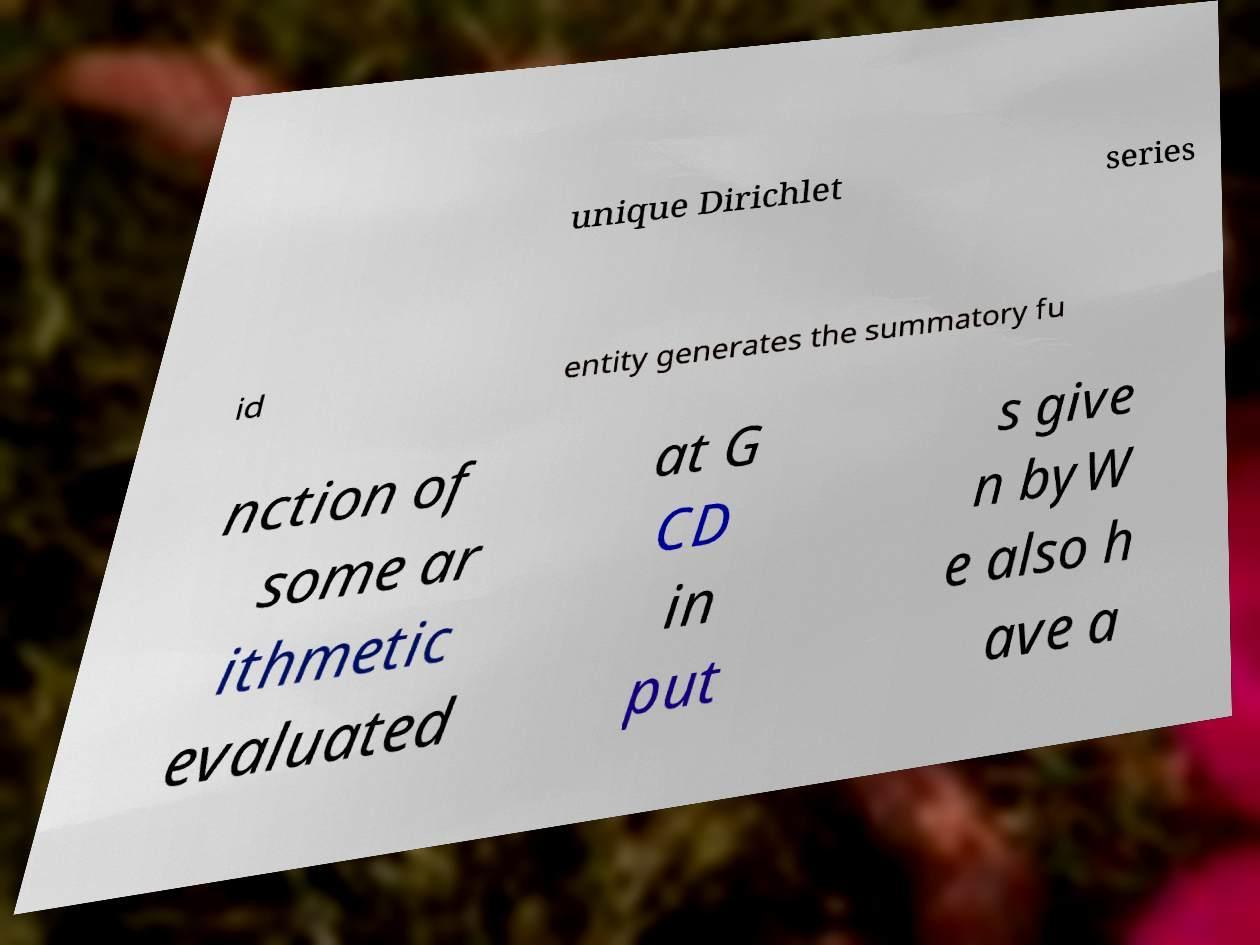Could you assist in decoding the text presented in this image and type it out clearly? unique Dirichlet series id entity generates the summatory fu nction of some ar ithmetic evaluated at G CD in put s give n byW e also h ave a 